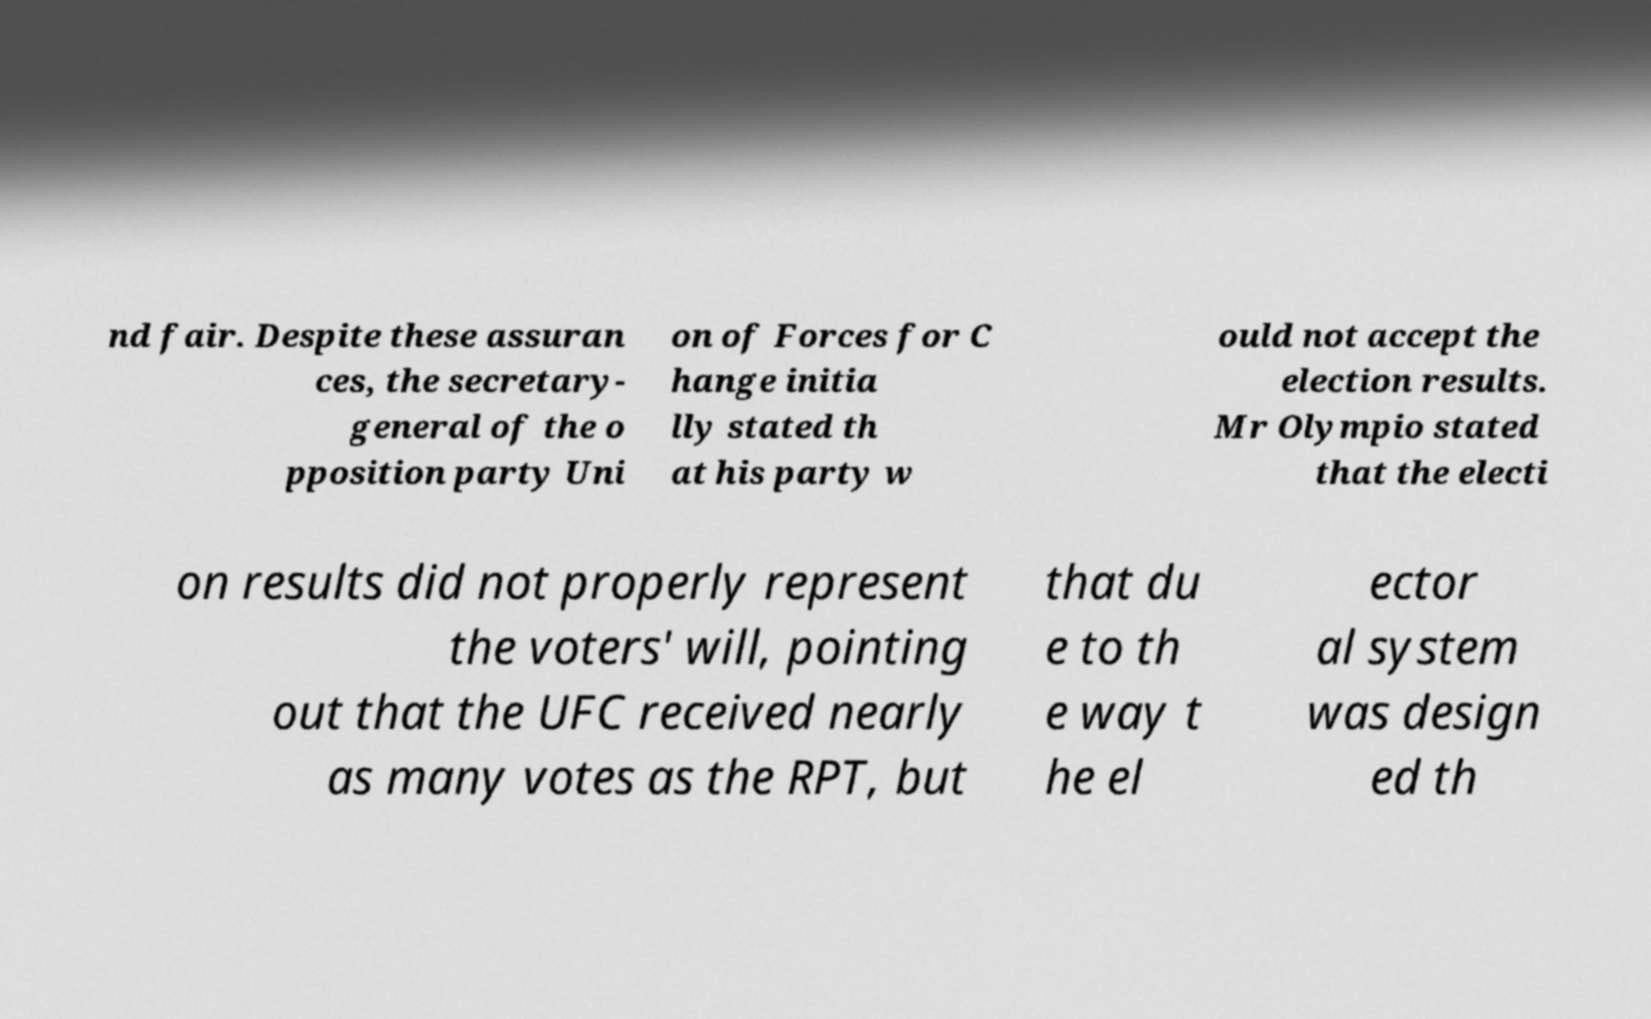Please read and relay the text visible in this image. What does it say? nd fair. Despite these assuran ces, the secretary- general of the o pposition party Uni on of Forces for C hange initia lly stated th at his party w ould not accept the election results. Mr Olympio stated that the electi on results did not properly represent the voters' will, pointing out that the UFC received nearly as many votes as the RPT, but that du e to th e way t he el ector al system was design ed th 